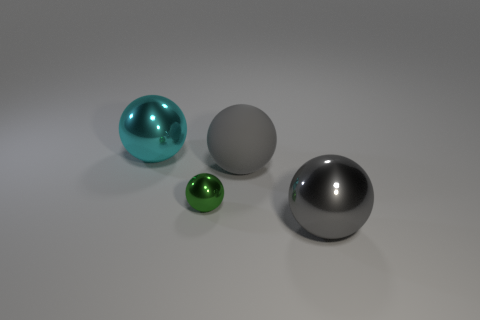What shape is the green object?
Provide a short and direct response. Sphere. What number of things are either green things or large balls right of the tiny object?
Offer a terse response. 3. Is the color of the large metal object to the right of the large cyan sphere the same as the tiny sphere?
Keep it short and to the point. No. What color is the sphere that is behind the small green shiny ball and on the right side of the small metallic ball?
Offer a very short reply. Gray. There is a gray thing that is in front of the rubber object; what is its material?
Offer a terse response. Metal. What is the size of the green shiny thing?
Provide a short and direct response. Small. How many brown things are balls or large metal things?
Offer a very short reply. 0. There is a gray thing to the left of the big metal thing in front of the cyan sphere; what size is it?
Ensure brevity in your answer.  Large. There is a big matte sphere; does it have the same color as the large metal object left of the gray metal sphere?
Your answer should be very brief. No. What number of other things are made of the same material as the green thing?
Your response must be concise. 2. 